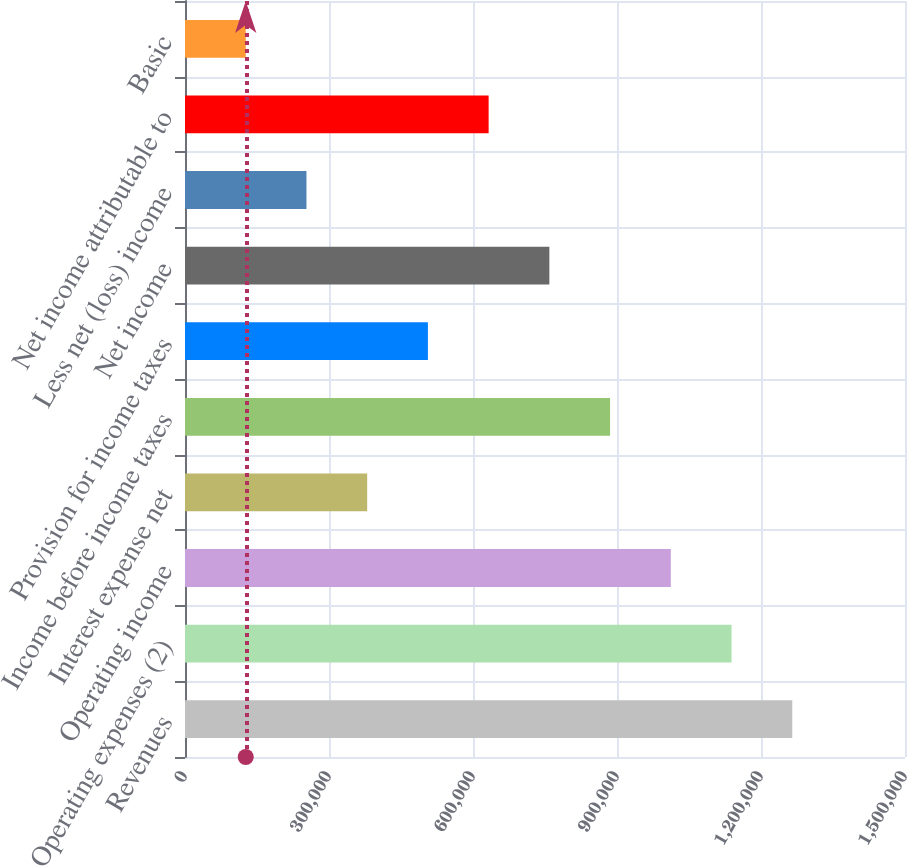Convert chart. <chart><loc_0><loc_0><loc_500><loc_500><bar_chart><fcel>Revenues<fcel>Operating expenses (2)<fcel>Operating income<fcel>Interest expense net<fcel>Income before income taxes<fcel>Provision for income taxes<fcel>Net income<fcel>Less net (loss) income<fcel>Net income attributable to<fcel>Basic<nl><fcel>1.26516e+06<fcel>1.13864e+06<fcel>1.01213e+06<fcel>379549<fcel>885611<fcel>506065<fcel>759096<fcel>253033<fcel>632580<fcel>126518<nl></chart> 